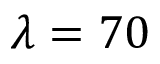Convert formula to latex. <formula><loc_0><loc_0><loc_500><loc_500>\lambda = 7 0</formula> 